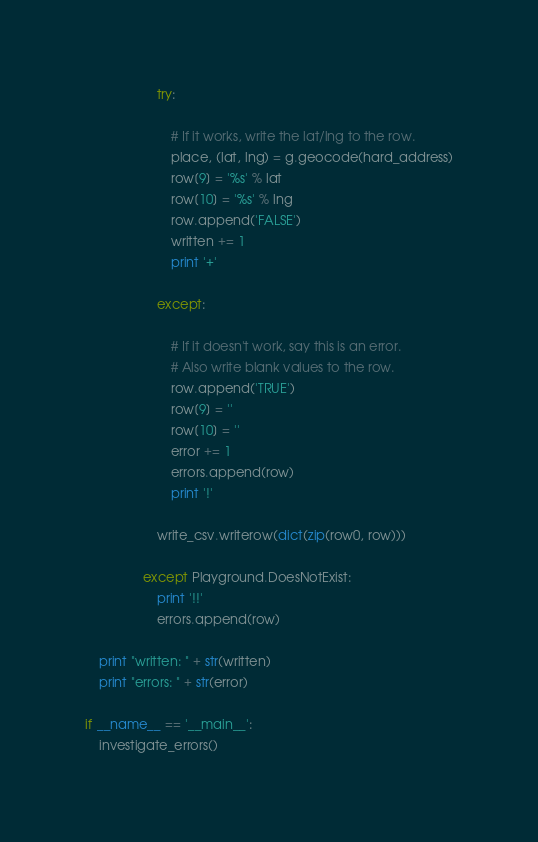Convert code to text. <code><loc_0><loc_0><loc_500><loc_500><_Python_>                    try:

                        # If it works, write the lat/lng to the row.
                        place, (lat, lng) = g.geocode(hard_address)
                        row[9] = '%s' % lat
                        row[10] = '%s' % lng
                        row.append('FALSE')
                        written += 1
                        print '+'

                    except:

                        # If it doesn't work, say this is an error.
                        # Also write blank values to the row.
                        row.append('TRUE')
                        row[9] = ''
                        row[10] = ''
                        error += 1
                        errors.append(row)
                        print '!'

                    write_csv.writerow(dict(zip(row0, row)))

                except Playground.DoesNotExist:
                    print '!!'
                    errors.append(row)

    print "written: " + str(written)
    print "errors: " + str(error)

if __name__ == '__main__':
    investigate_errors()
</code> 